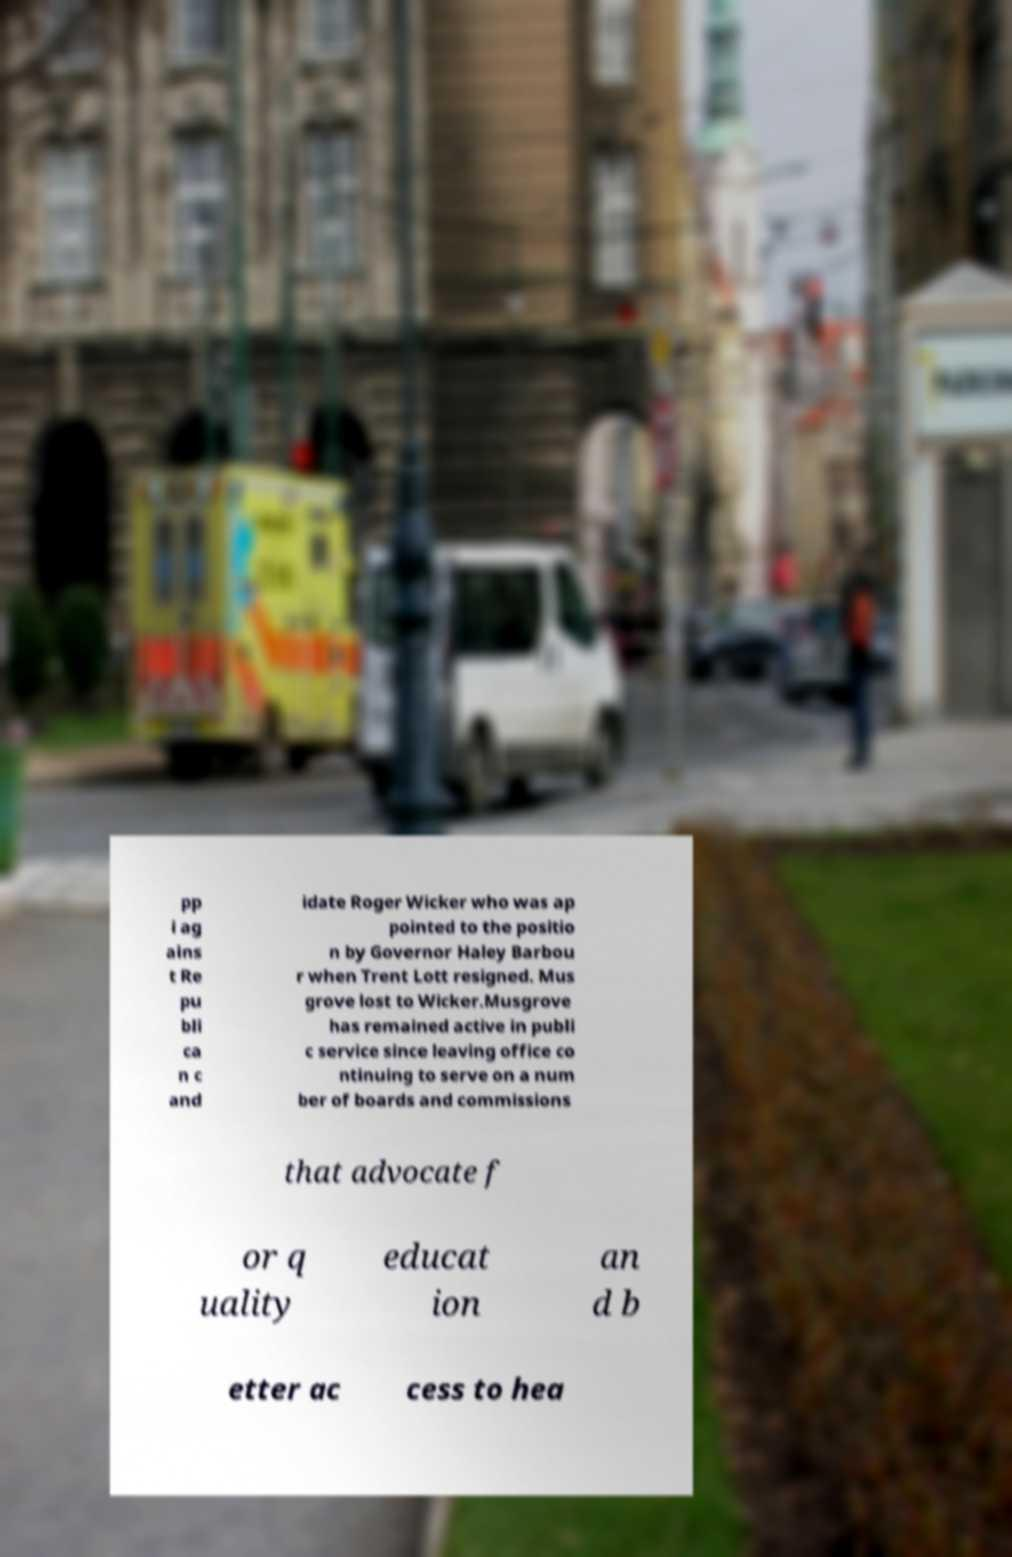What messages or text are displayed in this image? I need them in a readable, typed format. pp i ag ains t Re pu bli ca n c and idate Roger Wicker who was ap pointed to the positio n by Governor Haley Barbou r when Trent Lott resigned. Mus grove lost to Wicker.Musgrove has remained active in publi c service since leaving office co ntinuing to serve on a num ber of boards and commissions that advocate f or q uality educat ion an d b etter ac cess to hea 